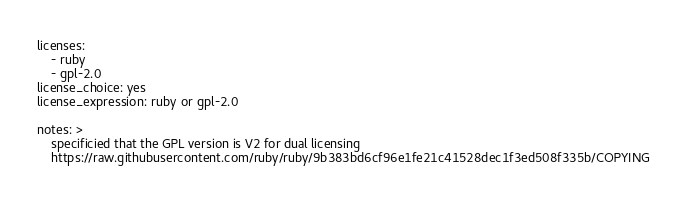Convert code to text. <code><loc_0><loc_0><loc_500><loc_500><_YAML_>licenses:
    - ruby
    - gpl-2.0
license_choice: yes
license_expression: ruby or gpl-2.0

notes: >
    specificied that the GPL version is V2 for dual licensing
    https://raw.githubusercontent.com/ruby/ruby/9b383bd6cf96e1fe21c41528dec1f3ed508f335b/COPYING</code> 